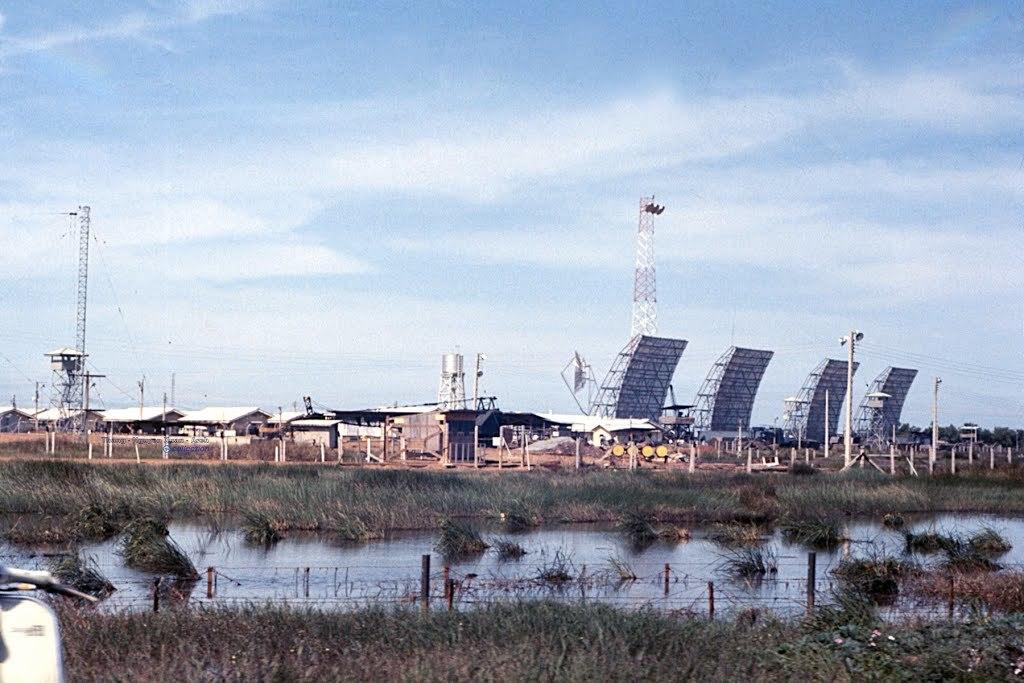What is the primary element visible in the image? There is water in the image. What type of vegetation is present near the water? There is greenery grass on either side of the water. What type of structures can be seen in the image? There are buildings and towers in the image. Can you describe any other objects present in the image? Yes, there are other objects in the image. How does the dust settle on the home in the image? There is no home or dust present in the image. What type of fold can be seen in the image? There is no fold present in the image. 